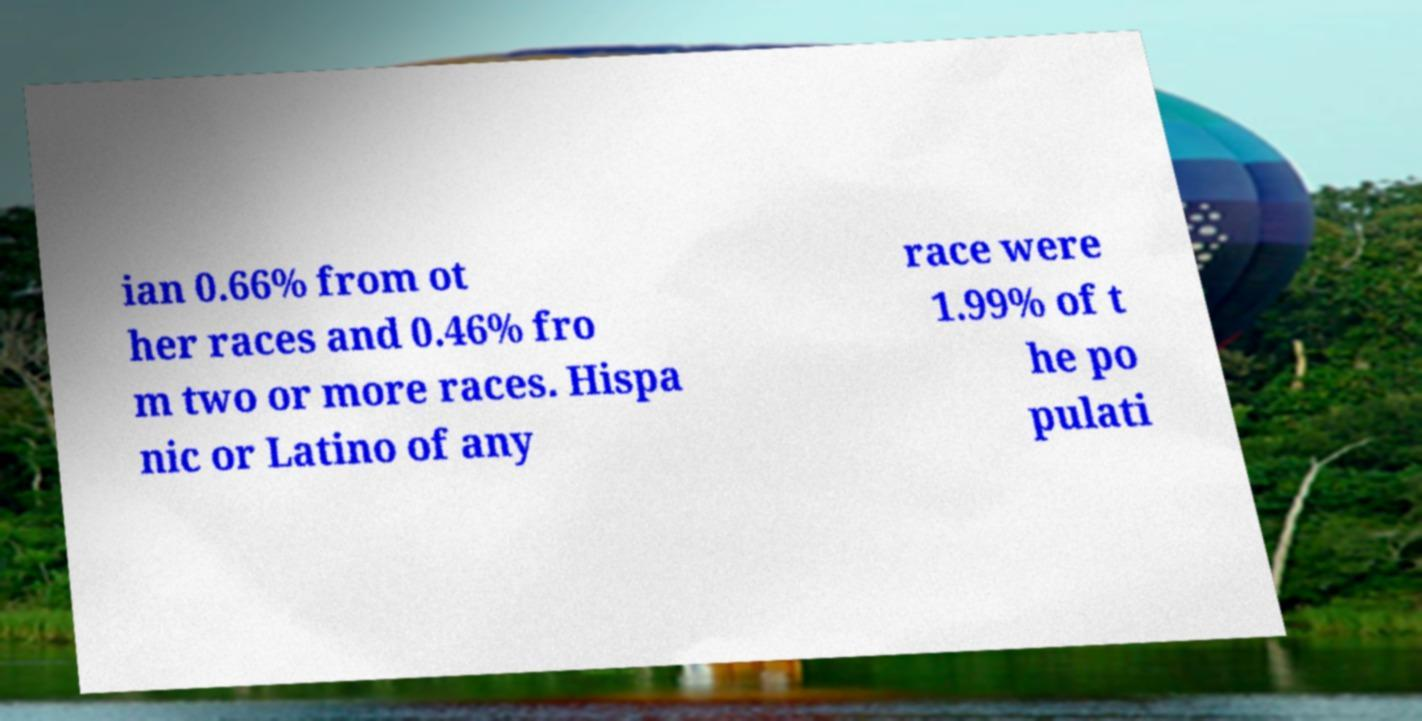What messages or text are displayed in this image? I need them in a readable, typed format. ian 0.66% from ot her races and 0.46% fro m two or more races. Hispa nic or Latino of any race were 1.99% of t he po pulati 